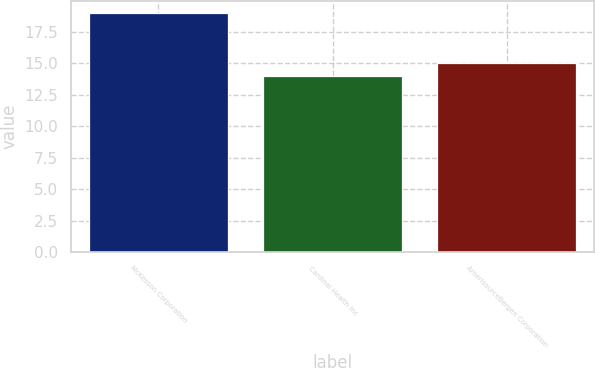Convert chart to OTSL. <chart><loc_0><loc_0><loc_500><loc_500><bar_chart><fcel>McKesson Corporation<fcel>Cardinal Health Inc<fcel>AmerisourceBergen Corporation<nl><fcel>19<fcel>14<fcel>15<nl></chart> 